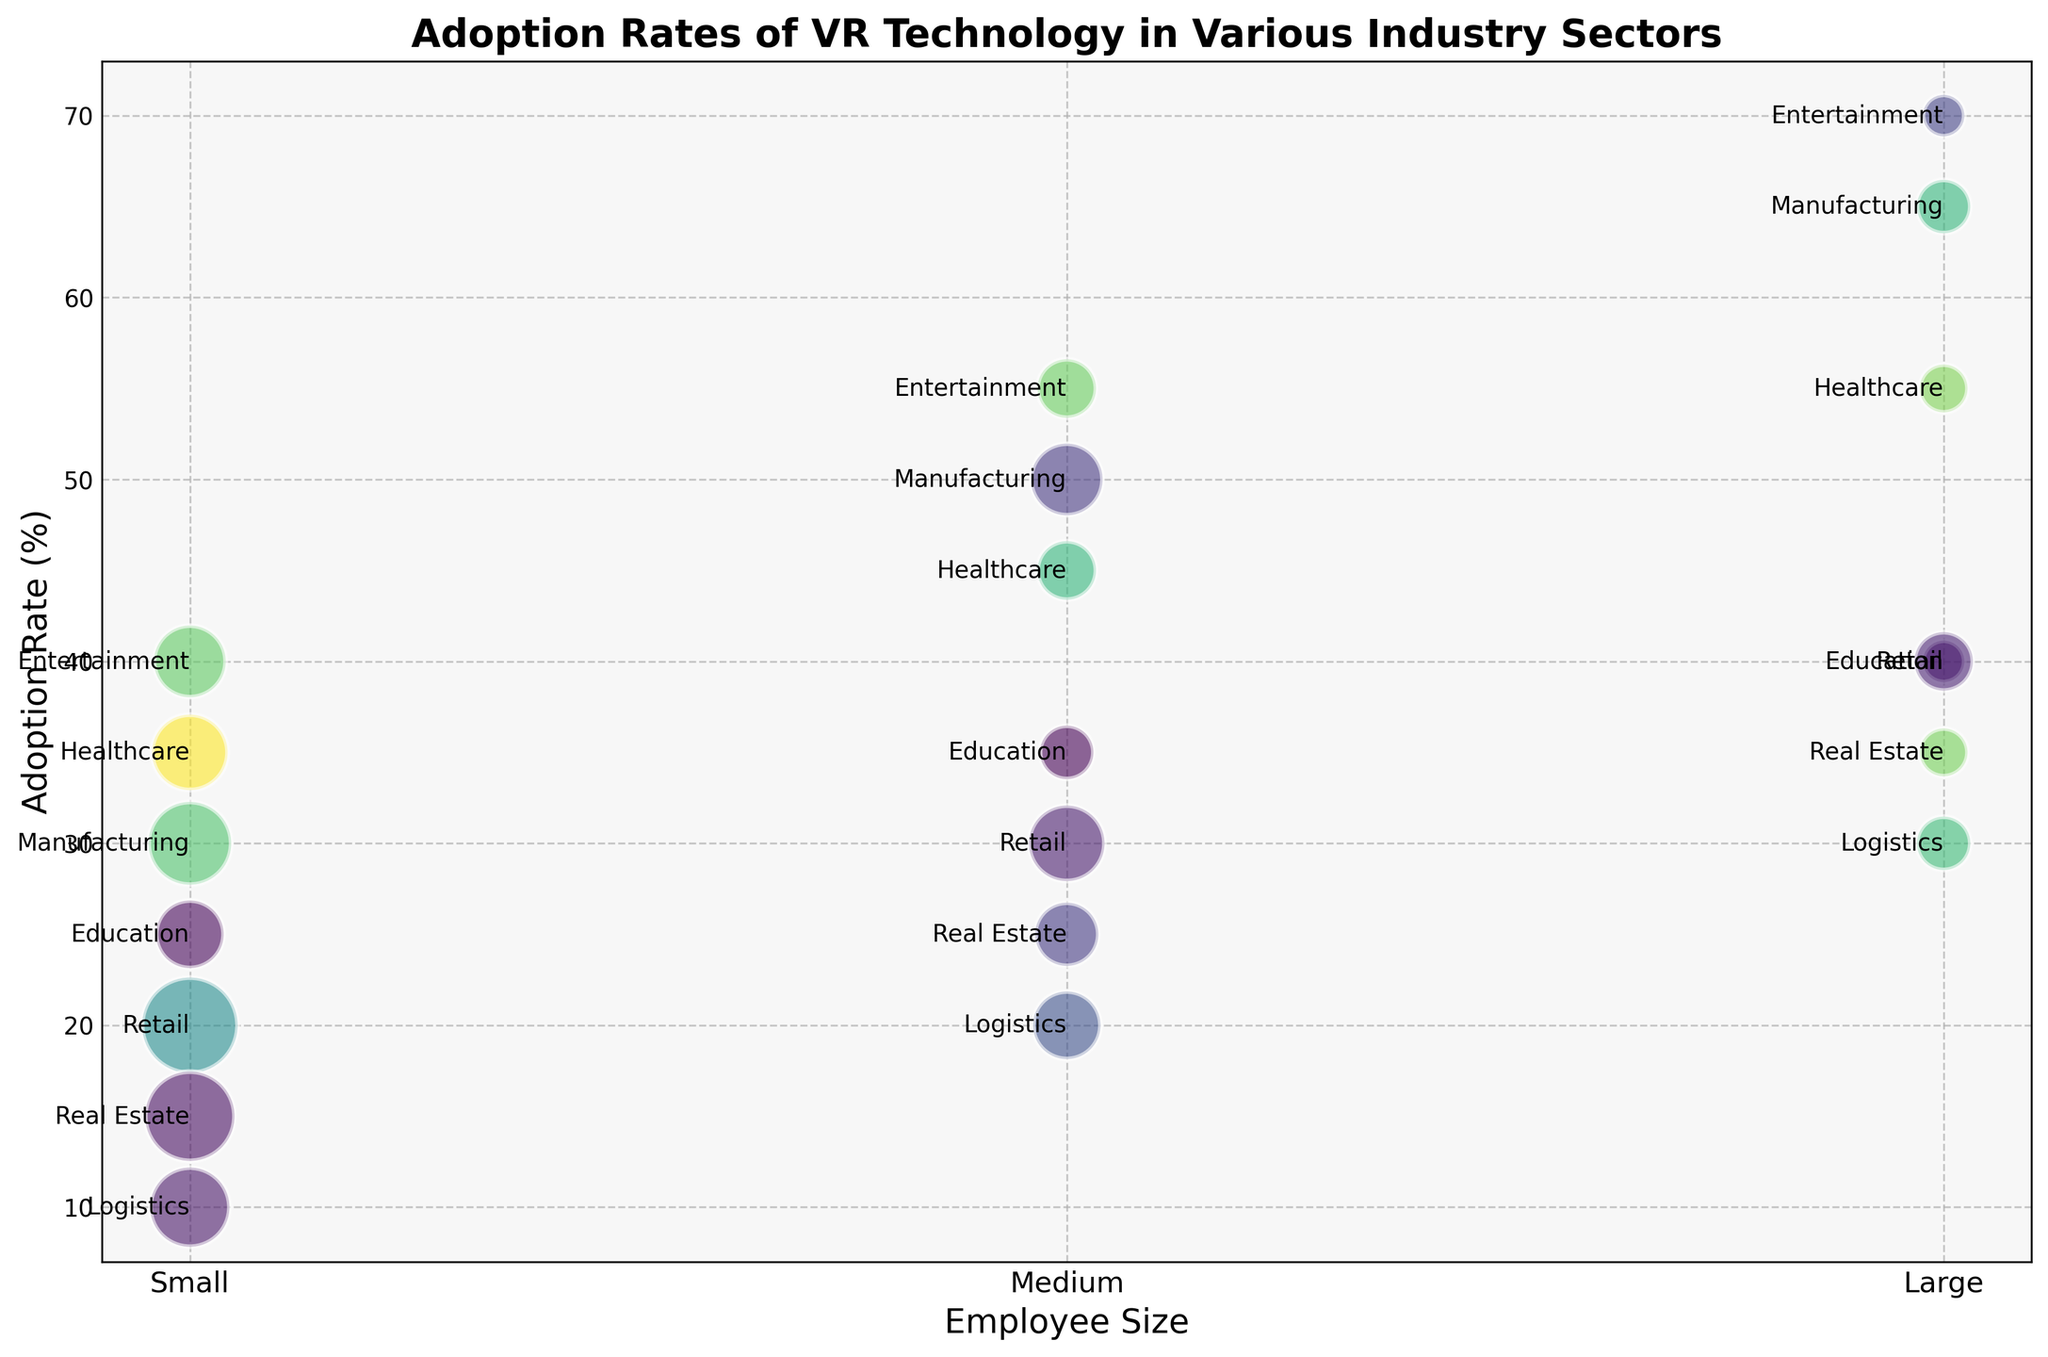Which industry sector has the highest adoption rate of VR technology for large-sized companies? The industry sector with the highest adoption rate for large-sized companies is the one with the highest bubble positioned on the 'Large' employee size column. Reading the chart, the highest bubble in this category is Entertainment, with an adoption rate of 70%.
Answer: Entertainment How does the adoption rate of VR technology for small-sized healthcare companies compare to small-sized education companies? To compare, locate the 'Small' employee size column and find the adoption rates for Healthcare and Education. Healthcare has a rate of 35%, while Education has a rate of 25%.
Answer: Healthcare has a higher adoption rate by 10% What is the average adoption rate of VR technology for medium-sized companies across all industry sectors? To find the average, sum the adoption rates for medium-sized companies in each sector and divide by the number of sectors. The rates are: 45 (Healthcare) + 35 (Education) + 50 (Manufacturing) + 30 (Retail) + 25 (Real Estate) + 55 (Entertainment) + 20 (Logistics). The sum is 260, and there are 7 sectors, so the average is 260/7 ≈ 37.14.
Answer: ≈ 37.14% Which industry sector has the largest bubble for small-sized companies? The size of the bubble is determined by the number of companies. Locate the 'Small' column and identify the largest bubble. Retail has the biggest bubble, indicating the highest number of companies (80).
Answer: Retail What is the difference in the adoption rate of VR technology between large-sized companies in Manufacturing and Entertainment industries? Locate the 'Large' employee size column and find the rates for Manufacturing (65%) and Entertainment (70%). The difference is 70% - 65% = 5%.
Answer: 5% Which employee size category in the Logistics sector has the lowest adoption rate of VR technology? To find the lowest rate in Logistics, compare the adoption rates across small (10%), medium (20%), and large (30%). The lowest rate is for small-sized companies.
Answer: Small How do adoption rates for medium-sized companies in Retail and Real Estate sectors compare? Find the adoption rates for medium-sized Retail (30%) and medium-sized Real Estate (25%). Retail has a higher adoption rate by 5%.
Answer: Retail, by 5% What is the difference in the number of companies between large-sized healthcare and large-sized real estate sectors? Compare the number of companies in the 'Large' employee size category for Healthcare (20) and Real Estate (20). The difference is 20 - 20 = 0.
Answer: 0 How many sectors have an adoption rate of VR technology above 50% for large-sized companies? Identify which sectors have a bubble positioned above the 50% mark in the 'Large' employee size category. They are Manufacturing (65%) and Entertainment (70%), so there are 2 sectors.
Answer: 2 